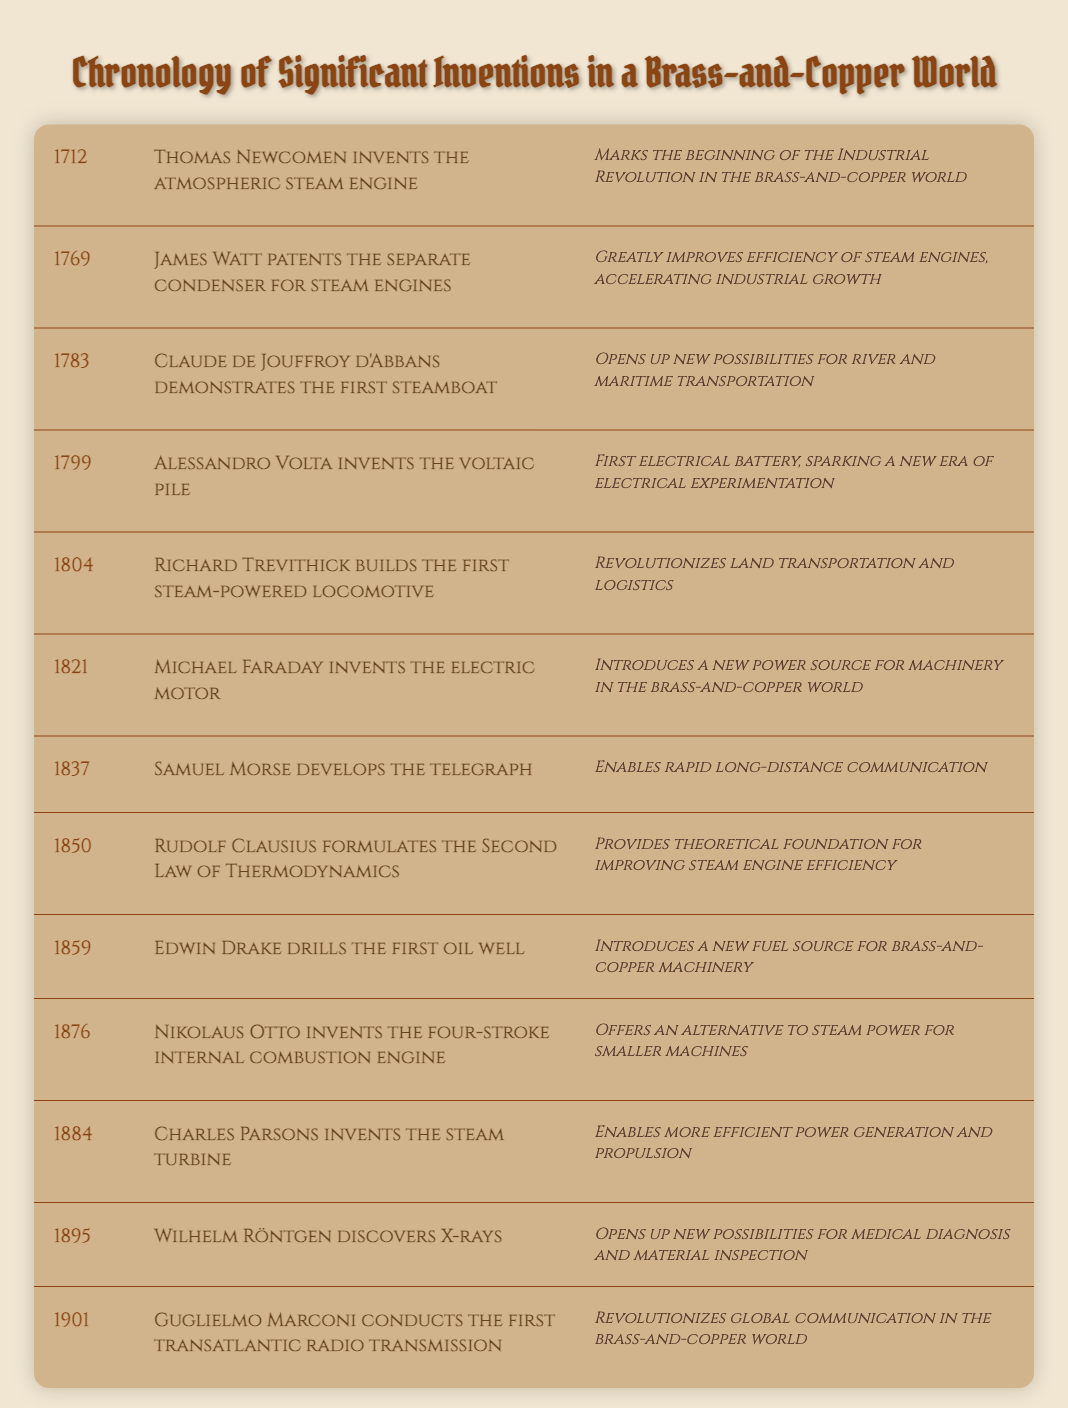What invention marked the beginning of the Industrial Revolution in the brass-and-copper world? The table indicates that Thomas Newcomen invented the atmospheric steam engine in 1712, which is noted as the beginning of the Industrial Revolution.
Answer: Atmospheric steam engine What year did Samuel Morse develop the telegraph? According to the table, Samuel Morse developed the telegraph in 1837.
Answer: 1837 Which invention significantly improved the efficiency of steam engines? The table states that James Watt patented the separate condenser for steam engines in 1769, which greatly improved their efficiency.
Answer: Separate condenser for steam engines True or False: The steam turbine was invented before the four-stroke internal combustion engine. According to the table, the steam turbine was invented by Charles Parsons in 1884, and the four-stroke internal combustion engine by Nikolaus Otto was invented in 1876. Thus, the statement is false.
Answer: False What is the average year of invention between the first steam engine and the telegraph? The first steam engine was invented in 1712 and the telegraph in 1837. To find the average, we need to sum the years: 1712 + 1837 = 3549, then divide by 2, leading to an average year of 1774.5 (approximately 1775).
Answer: 1775 Which event opened up new possibilities for river and maritime transportation? The table shows that Claude de Jouffroy d'Abbans demonstrated the first steamboat in 1783, which opened new possibilities for river and maritime transportation.
Answer: First steamboat How many years apart were the inventions of the voltaic pile and the electric motor? The voltaic pile was invented in 1799 and the electric motor in 1821. The difference in years is 1821 - 1799 = 22 years.
Answer: 22 years True or False: Edwin Drake drilled the first oil well after the discovery of X-rays. The timeline indicates that Edwin Drake drilled the first oil well in 1859 and Wilhelm Röntgen discovered X-rays in 1895. Therefore, this statement is true.
Answer: True What was the significance of Rudolf Clausius's formulation in 1850? The significance provided in the table states that Rudolf Clausius formulated the Second Law of Thermodynamics, which provided a theoretical foundation for improving steam engine efficiency.
Answer: Theoretical foundation for improving steam engine efficiency 